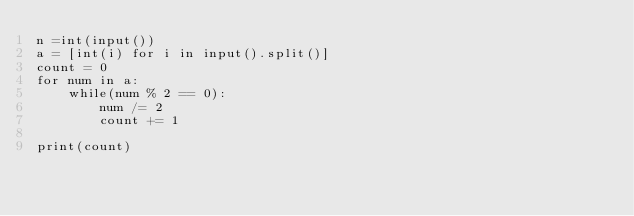<code> <loc_0><loc_0><loc_500><loc_500><_Python_>n =int(input())
a = [int(i) for i in input().split()]
count = 0
for num in a:
    while(num % 2 == 0):
        num /= 2
        count += 1

print(count)</code> 